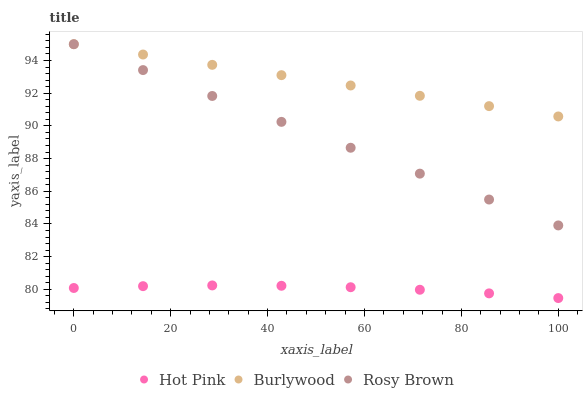Does Hot Pink have the minimum area under the curve?
Answer yes or no. Yes. Does Burlywood have the maximum area under the curve?
Answer yes or no. Yes. Does Rosy Brown have the minimum area under the curve?
Answer yes or no. No. Does Rosy Brown have the maximum area under the curve?
Answer yes or no. No. Is Rosy Brown the smoothest?
Answer yes or no. Yes. Is Hot Pink the roughest?
Answer yes or no. Yes. Is Hot Pink the smoothest?
Answer yes or no. No. Is Rosy Brown the roughest?
Answer yes or no. No. Does Hot Pink have the lowest value?
Answer yes or no. Yes. Does Rosy Brown have the lowest value?
Answer yes or no. No. Does Rosy Brown have the highest value?
Answer yes or no. Yes. Does Hot Pink have the highest value?
Answer yes or no. No. Is Hot Pink less than Burlywood?
Answer yes or no. Yes. Is Rosy Brown greater than Hot Pink?
Answer yes or no. Yes. Does Rosy Brown intersect Burlywood?
Answer yes or no. Yes. Is Rosy Brown less than Burlywood?
Answer yes or no. No. Is Rosy Brown greater than Burlywood?
Answer yes or no. No. Does Hot Pink intersect Burlywood?
Answer yes or no. No. 